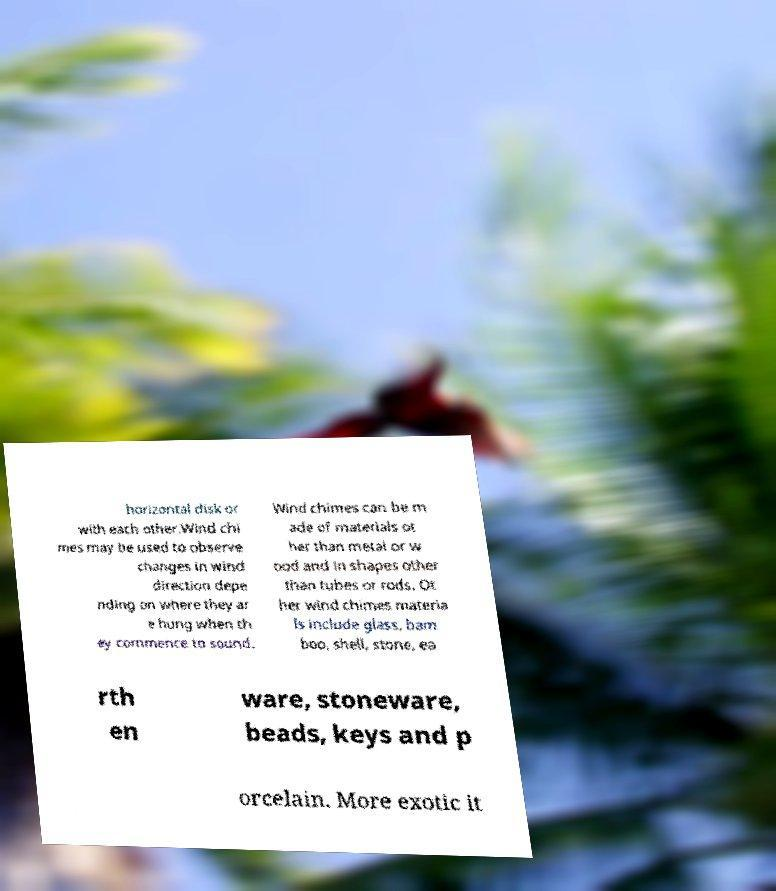There's text embedded in this image that I need extracted. Can you transcribe it verbatim? horizontal disk or with each other.Wind chi mes may be used to observe changes in wind direction depe nding on where they ar e hung when th ey commence to sound. Wind chimes can be m ade of materials ot her than metal or w ood and in shapes other than tubes or rods. Ot her wind chimes materia ls include glass, bam boo, shell, stone, ea rth en ware, stoneware, beads, keys and p orcelain. More exotic it 